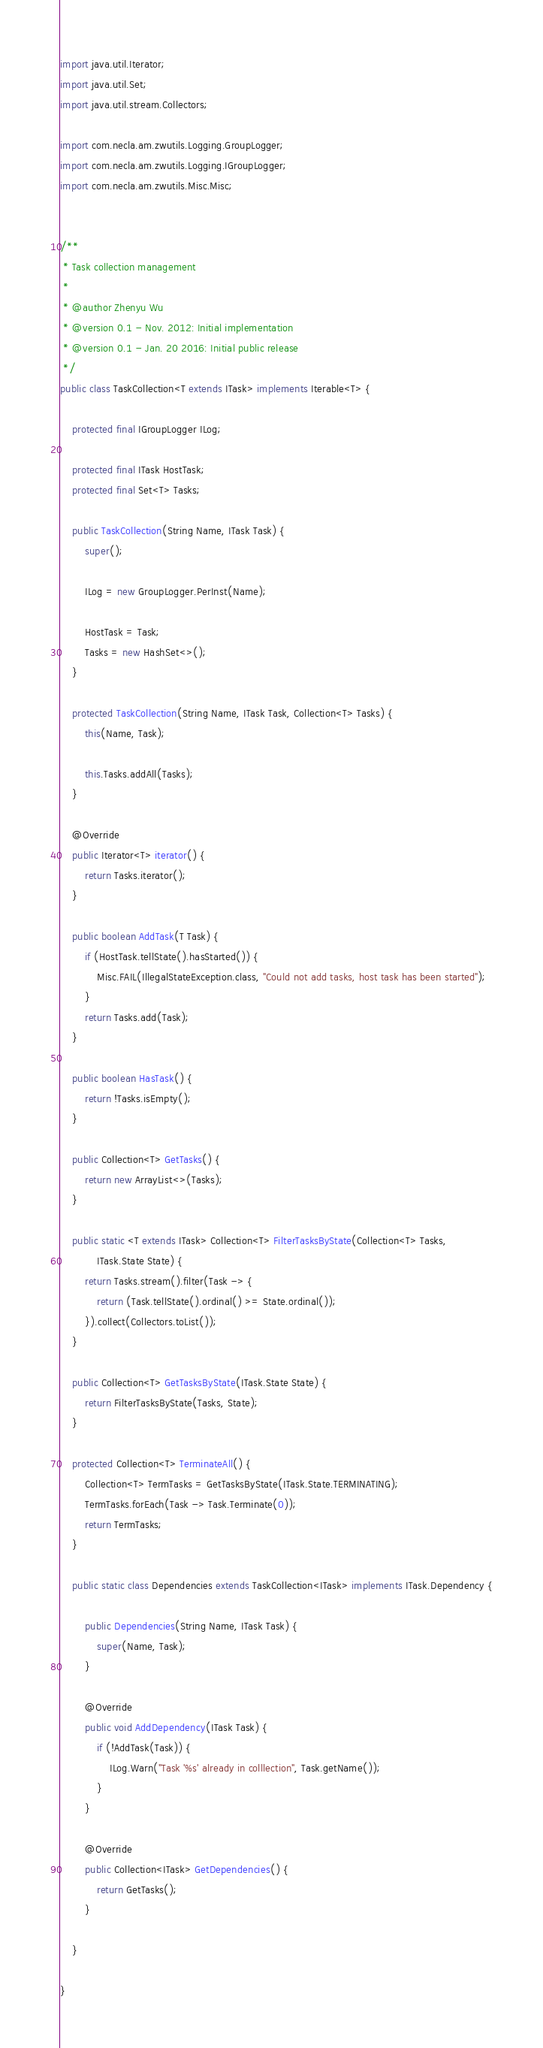<code> <loc_0><loc_0><loc_500><loc_500><_Java_>import java.util.Iterator;
import java.util.Set;
import java.util.stream.Collectors;

import com.necla.am.zwutils.Logging.GroupLogger;
import com.necla.am.zwutils.Logging.IGroupLogger;
import com.necla.am.zwutils.Misc.Misc;


/**
 * Task collection management
 *
 * @author Zhenyu Wu
 * @version 0.1 - Nov. 2012: Initial implementation
 * @version 0.1 - Jan. 20 2016: Initial public release
 */
public class TaskCollection<T extends ITask> implements Iterable<T> {
	
	protected final IGroupLogger ILog;
	
	protected final ITask HostTask;
	protected final Set<T> Tasks;
	
	public TaskCollection(String Name, ITask Task) {
		super();
		
		ILog = new GroupLogger.PerInst(Name);
		
		HostTask = Task;
		Tasks = new HashSet<>();
	}
	
	protected TaskCollection(String Name, ITask Task, Collection<T> Tasks) {
		this(Name, Task);
		
		this.Tasks.addAll(Tasks);
	}
	
	@Override
	public Iterator<T> iterator() {
		return Tasks.iterator();
	}
	
	public boolean AddTask(T Task) {
		if (HostTask.tellState().hasStarted()) {
			Misc.FAIL(IllegalStateException.class, "Could not add tasks, host task has been started");
		}
		return Tasks.add(Task);
	}
	
	public boolean HasTask() {
		return !Tasks.isEmpty();
	}
	
	public Collection<T> GetTasks() {
		return new ArrayList<>(Tasks);
	}
	
	public static <T extends ITask> Collection<T> FilterTasksByState(Collection<T> Tasks,
			ITask.State State) {
		return Tasks.stream().filter(Task -> {
			return (Task.tellState().ordinal() >= State.ordinal());
		}).collect(Collectors.toList());
	}
	
	public Collection<T> GetTasksByState(ITask.State State) {
		return FilterTasksByState(Tasks, State);
	}
	
	protected Collection<T> TerminateAll() {
		Collection<T> TermTasks = GetTasksByState(ITask.State.TERMINATING);
		TermTasks.forEach(Task -> Task.Terminate(0));
		return TermTasks;
	}
	
	public static class Dependencies extends TaskCollection<ITask> implements ITask.Dependency {
		
		public Dependencies(String Name, ITask Task) {
			super(Name, Task);
		}
		
		@Override
		public void AddDependency(ITask Task) {
			if (!AddTask(Task)) {
				ILog.Warn("Task '%s' already in colllection", Task.getName());
			}
		}
		
		@Override
		public Collection<ITask> GetDependencies() {
			return GetTasks();
		}
		
	}
	
}
</code> 